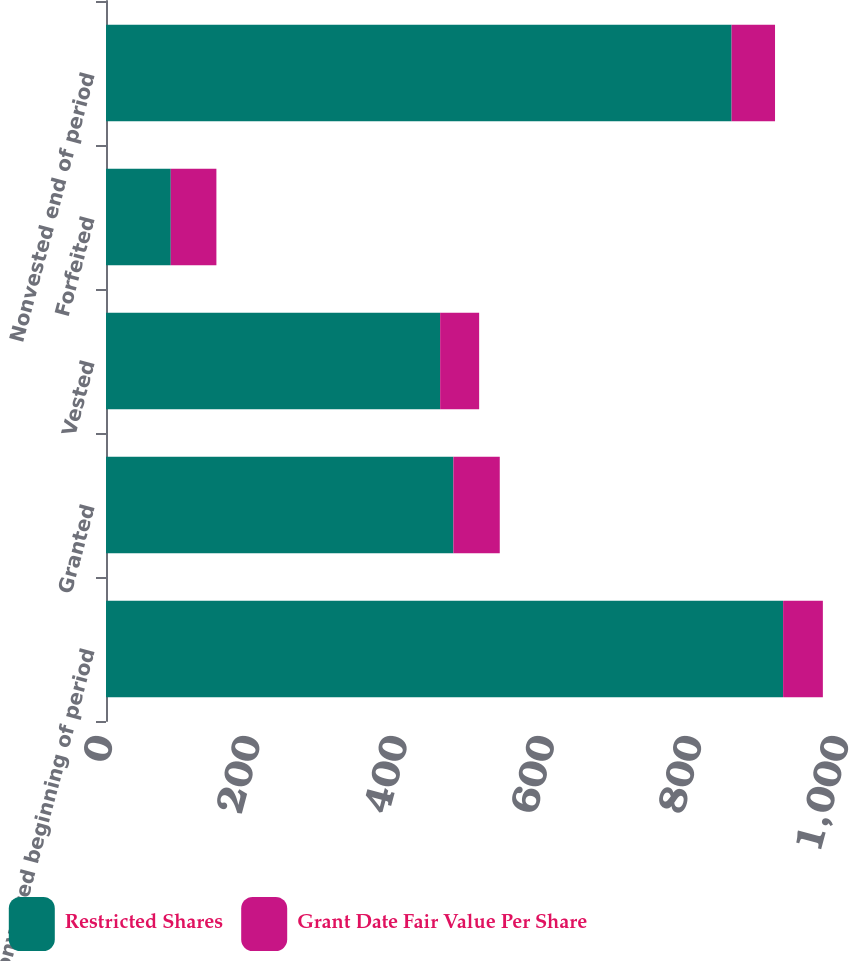<chart> <loc_0><loc_0><loc_500><loc_500><stacked_bar_chart><ecel><fcel>Nonvested beginning of period<fcel>Granted<fcel>Vested<fcel>Forfeited<fcel>Nonvested end of period<nl><fcel>Restricted Shares<fcel>920<fcel>472<fcel>454<fcel>88<fcel>850<nl><fcel>Grant Date Fair Value Per Share<fcel>54<fcel>63<fcel>53<fcel>62<fcel>59<nl></chart> 